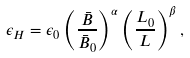<formula> <loc_0><loc_0><loc_500><loc_500>\epsilon _ { H } = \epsilon _ { 0 } \left ( \frac { \bar { B } } { \bar { B } _ { 0 } } \right ) ^ { \alpha } \left ( \frac { L _ { 0 } } { L } \right ) ^ { \beta } ,</formula> 